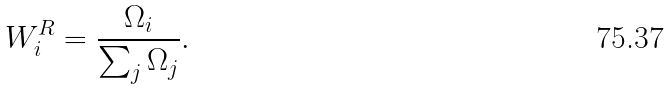<formula> <loc_0><loc_0><loc_500><loc_500>W ^ { R } _ { i } = \frac { \Omega _ { i } } { \sum _ { j } \Omega _ { j } } .</formula> 